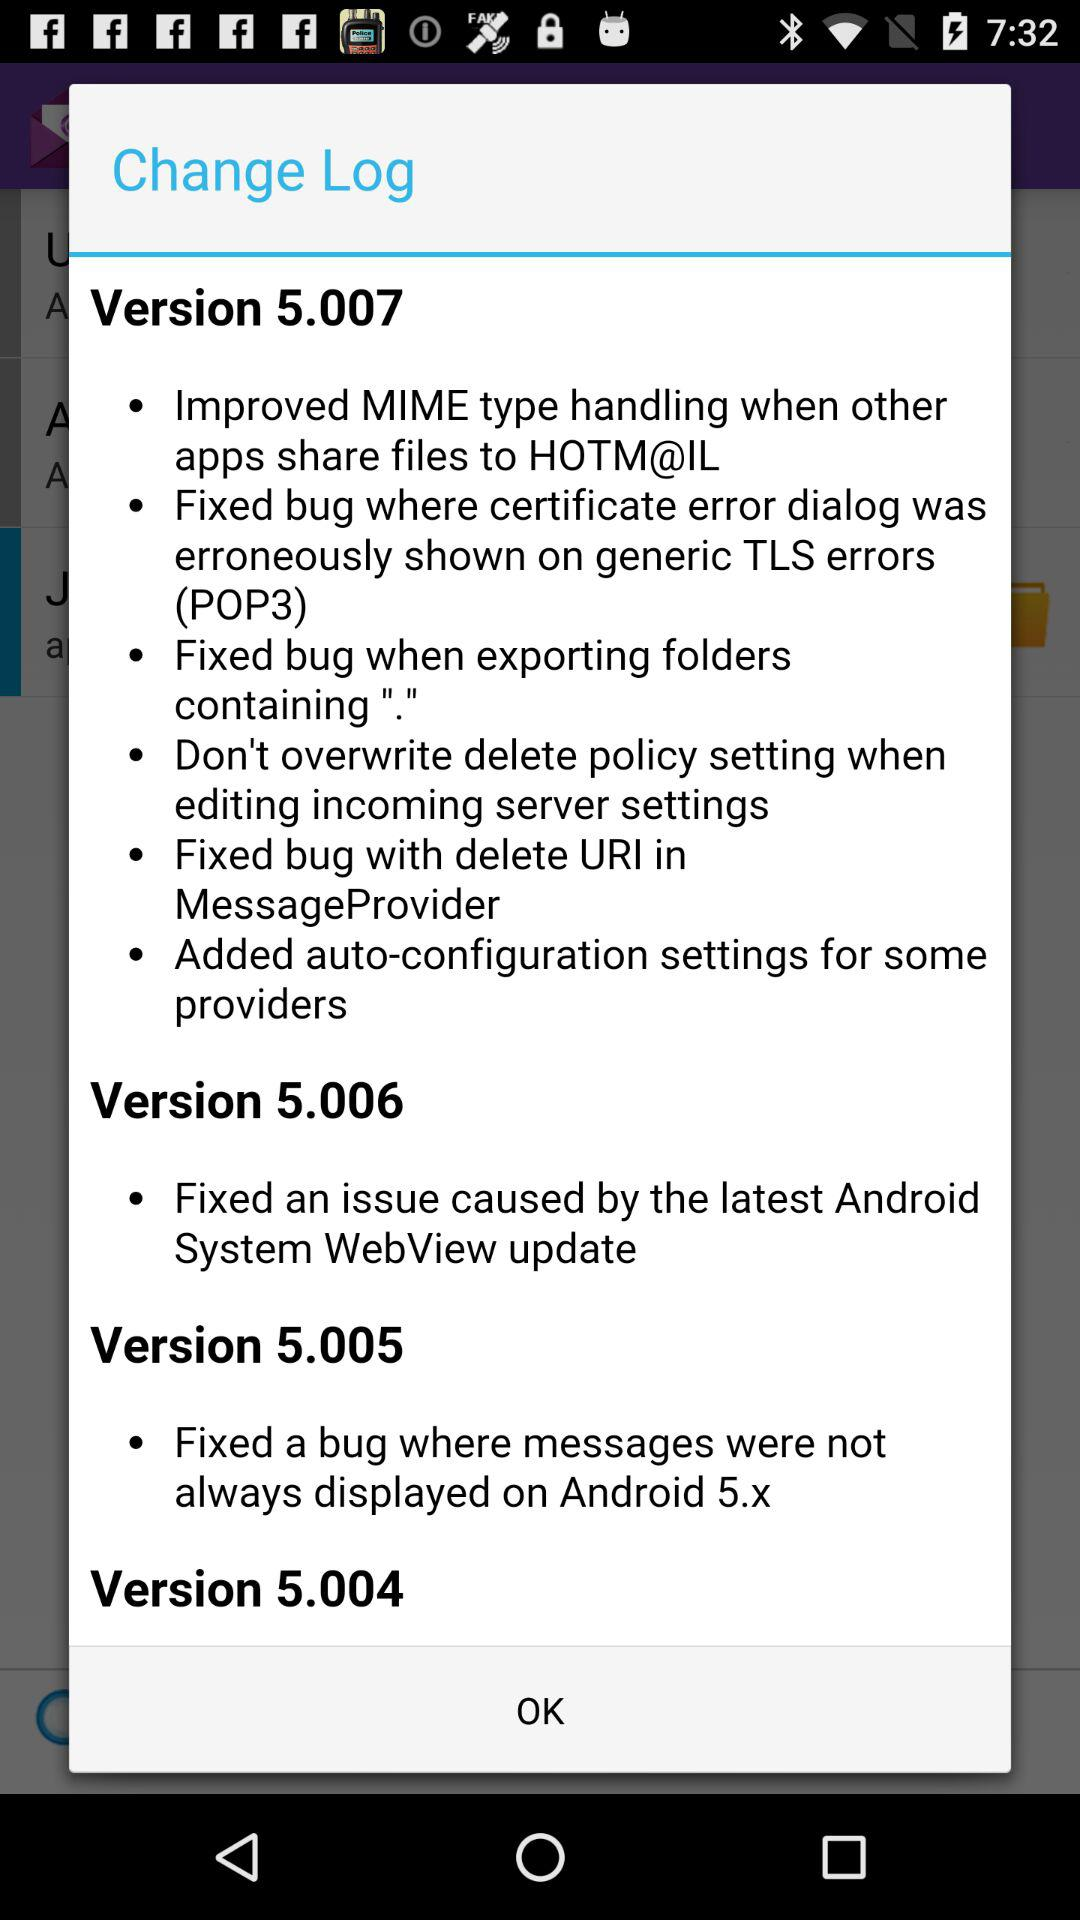Which version fixed a bug where messages were not always displayed? The version that fixed a bug where messages were not always displayed is 5.005. 